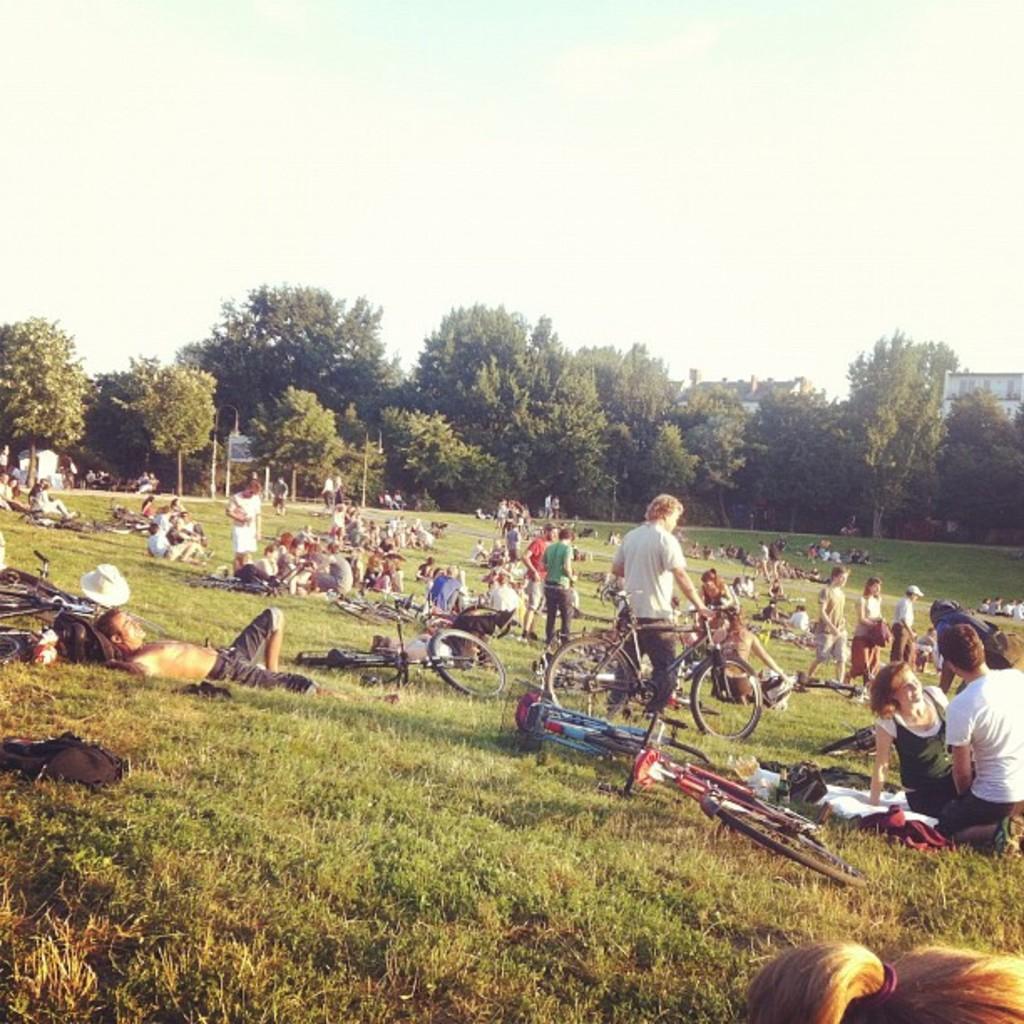Could you give a brief overview of what you see in this image? In this image, we can see many people and bicycles on the ground and in the background, there are trees, buildings, poles and boards. At the top, there is sky. 